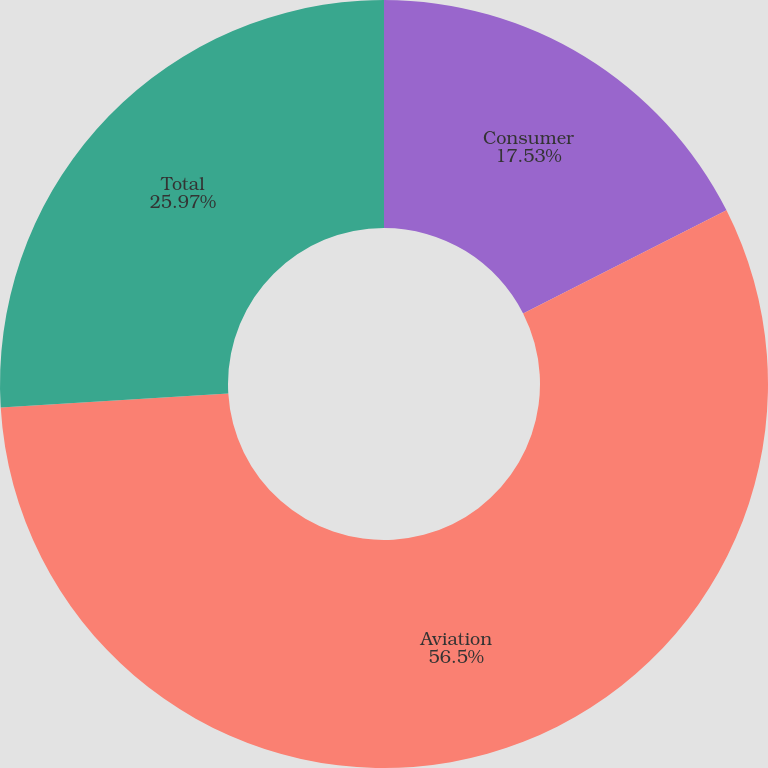Convert chart to OTSL. <chart><loc_0><loc_0><loc_500><loc_500><pie_chart><fcel>Consumer<fcel>Aviation<fcel>Total<nl><fcel>17.53%<fcel>56.49%<fcel>25.97%<nl></chart> 